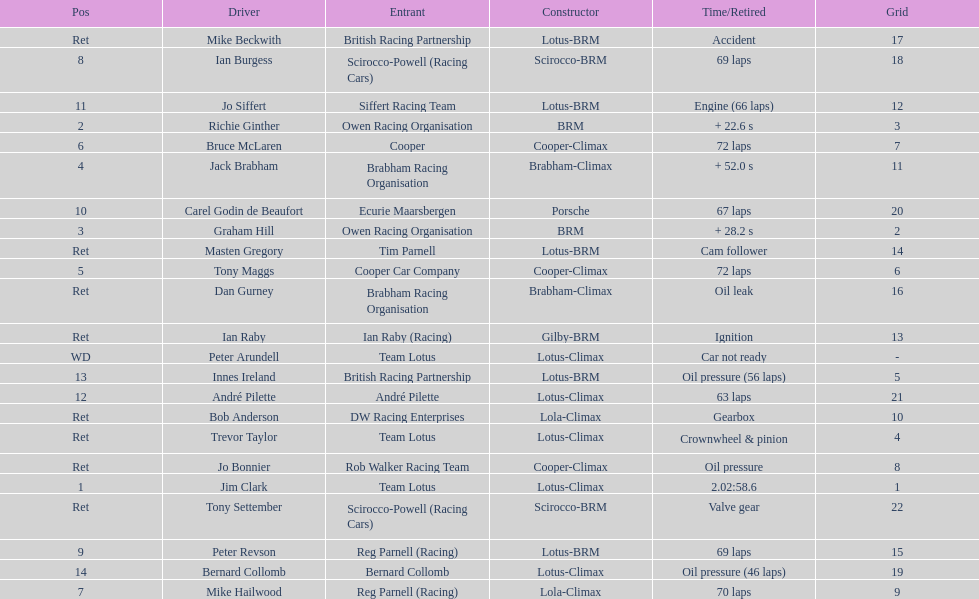Who are all the drivers? Jim Clark, Richie Ginther, Graham Hill, Jack Brabham, Tony Maggs, Bruce McLaren, Mike Hailwood, Ian Burgess, Peter Revson, Carel Godin de Beaufort, Jo Siffert, André Pilette, Innes Ireland, Bernard Collomb, Ian Raby, Dan Gurney, Mike Beckwith, Masten Gregory, Trevor Taylor, Jo Bonnier, Tony Settember, Bob Anderson, Peter Arundell. What position were they in? 1, 2, 3, 4, 5, 6, 7, 8, 9, 10, 11, 12, 13, 14, Ret, Ret, Ret, Ret, Ret, Ret, Ret, Ret, WD. What about just tony maggs and jo siffert? 5, 11. And between them, which driver came in earlier? Tony Maggs. 